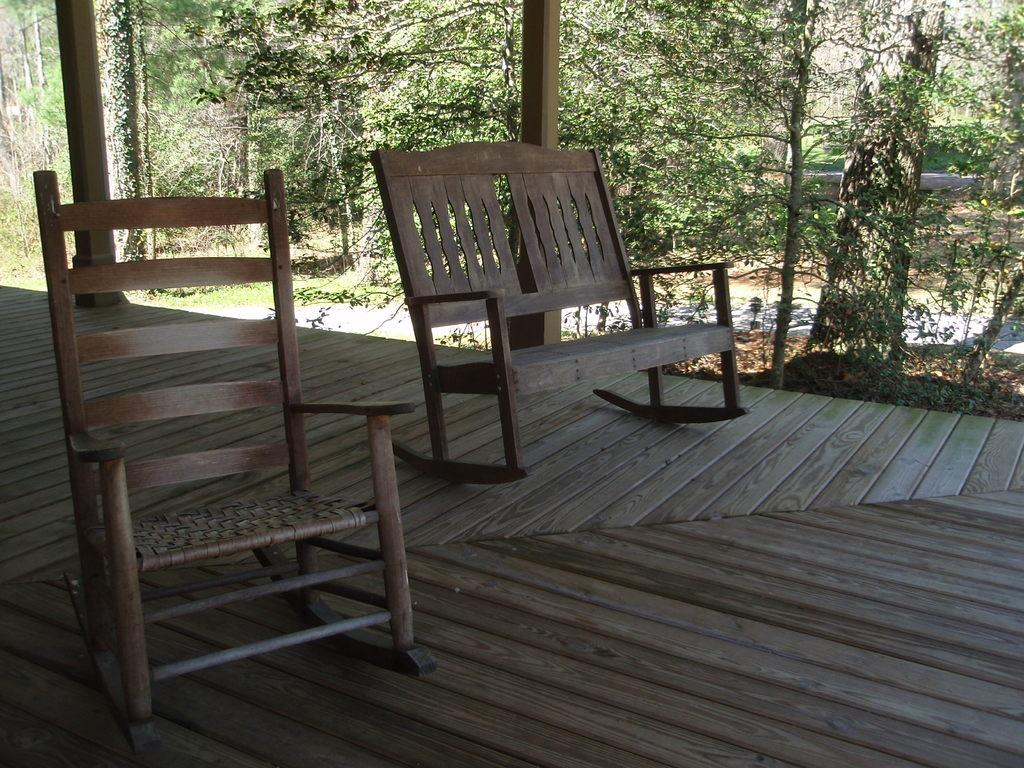What type of chairs are in the image? There are wooden chairs in the image. What can be seen in the background of the image? Trees are visible in the image. Where is the harbor located in the image? There is no harbor present in the image. What type of box can be seen on the wooden chairs? There is no box present on the wooden chairs in the image. 